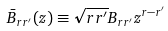<formula> <loc_0><loc_0><loc_500><loc_500>\bar { B } _ { r r ^ { \prime } } ( z ) \equiv \sqrt { r r ^ { \prime } } B _ { r r ^ { \prime } } z ^ { r - r ^ { \prime } }</formula> 